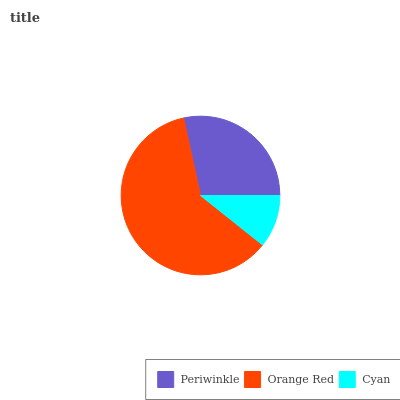Is Cyan the minimum?
Answer yes or no. Yes. Is Orange Red the maximum?
Answer yes or no. Yes. Is Orange Red the minimum?
Answer yes or no. No. Is Cyan the maximum?
Answer yes or no. No. Is Orange Red greater than Cyan?
Answer yes or no. Yes. Is Cyan less than Orange Red?
Answer yes or no. Yes. Is Cyan greater than Orange Red?
Answer yes or no. No. Is Orange Red less than Cyan?
Answer yes or no. No. Is Periwinkle the high median?
Answer yes or no. Yes. Is Periwinkle the low median?
Answer yes or no. Yes. Is Orange Red the high median?
Answer yes or no. No. Is Orange Red the low median?
Answer yes or no. No. 